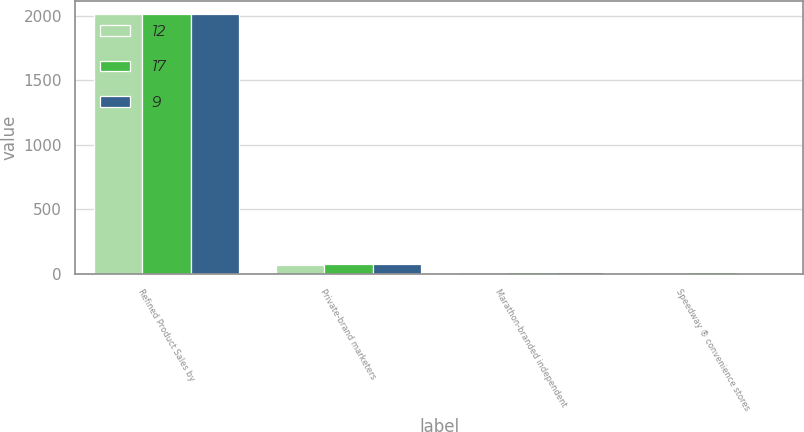Convert chart. <chart><loc_0><loc_0><loc_500><loc_500><stacked_bar_chart><ecel><fcel>Refined Product Sales by<fcel>Private-brand marketers<fcel>Marathon-branded independent<fcel>Speedway ® convenience stores<nl><fcel>12<fcel>2015<fcel>69<fcel>14<fcel>17<nl><fcel>17<fcel>2014<fcel>73<fcel>15<fcel>12<nl><fcel>9<fcel>2013<fcel>75<fcel>16<fcel>9<nl></chart> 